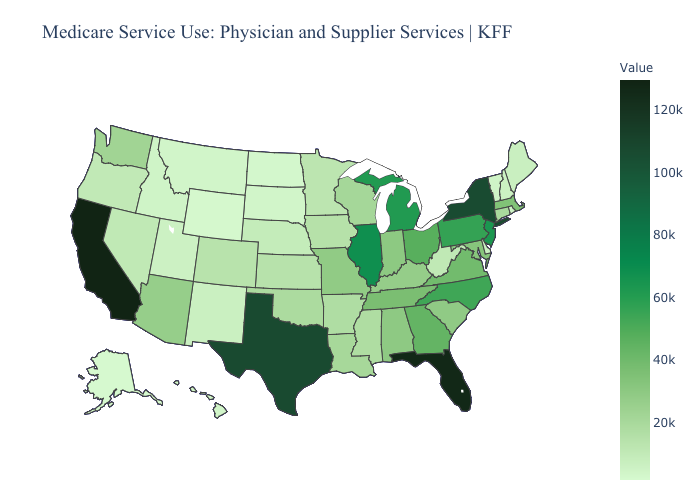Among the states that border Nebraska , does Kansas have the highest value?
Be succinct. No. Does Mississippi have the highest value in the USA?
Write a very short answer. No. Is the legend a continuous bar?
Keep it brief. Yes. 